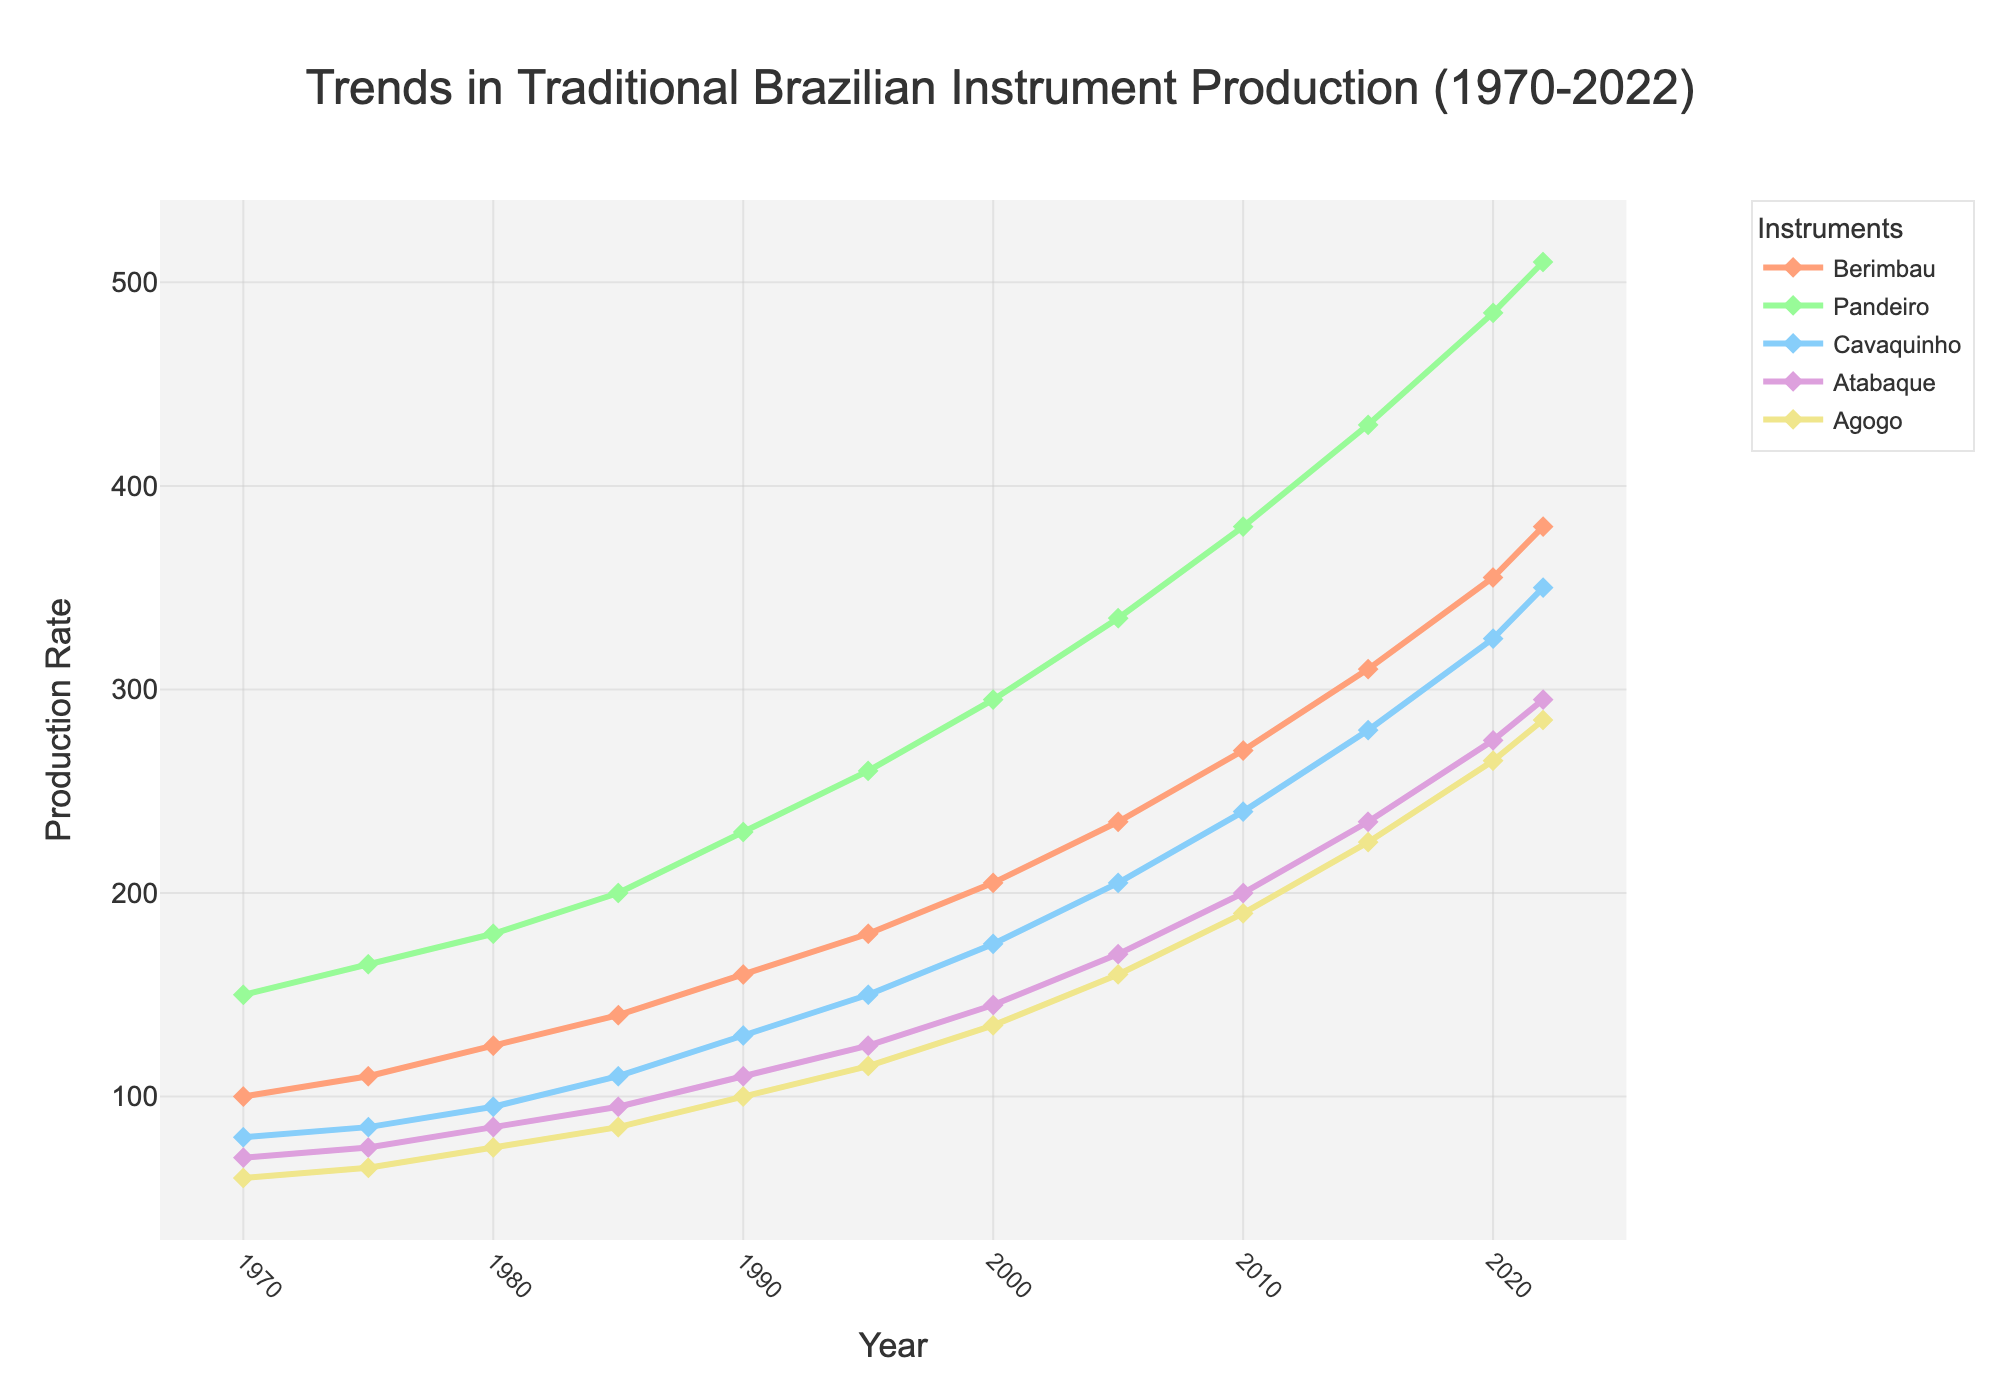What's the overall trend in Berimbau production from 1970 to 2022? The line for Berimbau shows a steady increase from 100 units in 1970 to 380 units in 2022. This indicates a consistent rise in production over the years.
Answer: A steady increase Which instrument had the highest production rate in 2022? The lines for the instruments show that the Pandeiro had the highest production rate in 2022, reaching 510 units.
Answer: Pandeiro How did the production rate of Atabaque change between 2000 and 2022? The Atabaque production line starts at 145 units in 2000 and increases to 295 units in 2022. This represents a rise in production over these years.
Answer: Increased Compare the production rates of Berimbau and Cavaquinho in 1990. In 1990, the lines show that Berimbau production was at 160 units while Cavaquinho production was at 130 units.
Answer: Berimbau had higher production What’s the average production rate for Cavaquinho between 1970 and 2022? To find the average, sum the production rates for each year and divide by the number of years (80+85+95+110+130+150+175+205+240+280+325+350)/12. The total is 2225, so the average is 2225/12.
Answer: 185.42 Which instrument had the smallest production rate increase between 1970 and 2022? The difference in production from 1970 to 2022 for each instrument is calculated: Berimbau (380-100=280), Pandeiro (510-150=360), Cavaquinho (350-80=270), Atabaque (295-70=225), Agogo (285-60=225). The Agogo and Atabaque both had the smallest increase of 225 units.
Answer: Agogo and Atabaque What is the difference between the production rates of the highest and lowest instruments in 1985? In 1985, Pandeiro had the highest production rate at 200 units, and Agogo had the lowest at 85 units. The difference is 200-85.
Answer: 115 How much did Pandeiro production increase between 2005 and 2022? In 2005, Pandeiro production was 335 units, and in 2022, it was 510 units. The increase is 510-335.
Answer: 175 Which instrument had the steepest increase in production rates between 2010 and 2020? The slopes of the lines between 2010 and 2020 show the steepest increase. Pandeiro increased from 380 to 485 units, a rise of 105 units, which is the steepest compared to other instruments.
Answer: Pandeiro What is the median production rate of Agogo over the observed years? The sorted production rates for Agogo are [60, 65, 75, 85, 100, 115, 135, 160, 190, 225, 265, 285]. For 12 values, the median is the average of the 6th and 7th values (115+135)/2.
Answer: 125 